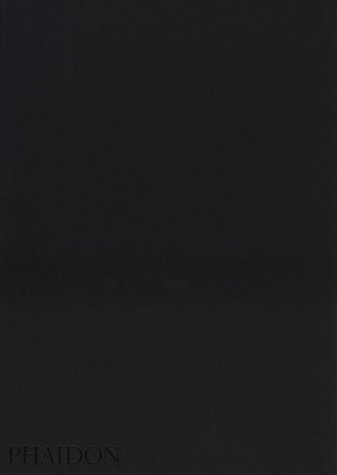Is this book related to Christian Books & Bibles? Yes, the book is related to 'Christian Books & Bibles,' exploring religious and cultural themes within the Mennonite community. 